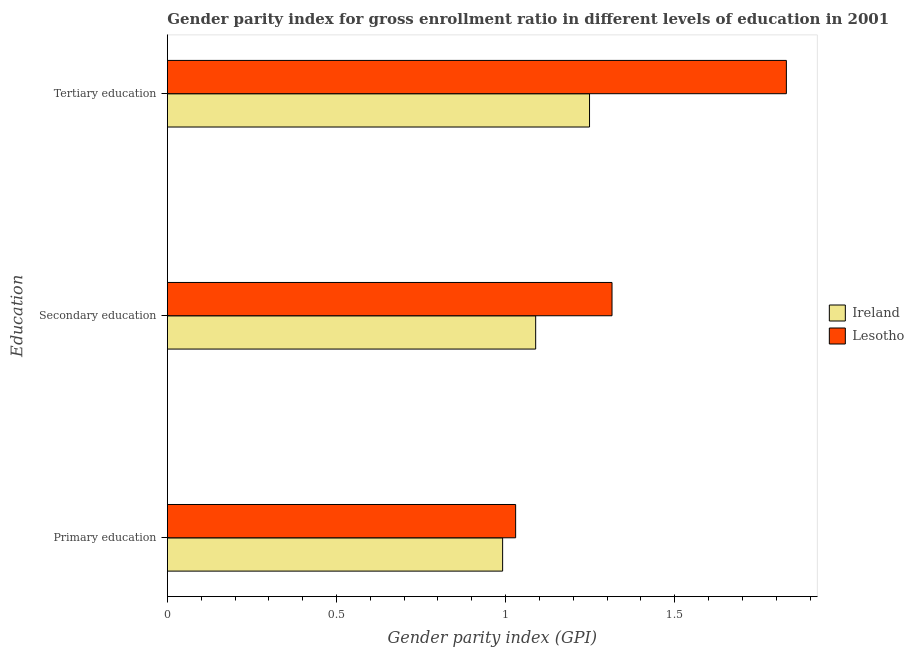How many different coloured bars are there?
Offer a terse response. 2. Are the number of bars per tick equal to the number of legend labels?
Keep it short and to the point. Yes. Are the number of bars on each tick of the Y-axis equal?
Your answer should be very brief. Yes. How many bars are there on the 1st tick from the top?
Ensure brevity in your answer.  2. What is the label of the 2nd group of bars from the top?
Keep it short and to the point. Secondary education. What is the gender parity index in secondary education in Ireland?
Make the answer very short. 1.09. Across all countries, what is the maximum gender parity index in primary education?
Offer a very short reply. 1.03. Across all countries, what is the minimum gender parity index in secondary education?
Keep it short and to the point. 1.09. In which country was the gender parity index in tertiary education maximum?
Give a very brief answer. Lesotho. In which country was the gender parity index in secondary education minimum?
Provide a succinct answer. Ireland. What is the total gender parity index in tertiary education in the graph?
Your response must be concise. 3.08. What is the difference between the gender parity index in tertiary education in Lesotho and that in Ireland?
Give a very brief answer. 0.58. What is the difference between the gender parity index in tertiary education in Lesotho and the gender parity index in secondary education in Ireland?
Offer a terse response. 0.74. What is the average gender parity index in primary education per country?
Provide a succinct answer. 1.01. What is the difference between the gender parity index in secondary education and gender parity index in primary education in Ireland?
Offer a very short reply. 0.1. What is the ratio of the gender parity index in secondary education in Ireland to that in Lesotho?
Provide a short and direct response. 0.83. Is the gender parity index in secondary education in Ireland less than that in Lesotho?
Give a very brief answer. Yes. Is the difference between the gender parity index in primary education in Lesotho and Ireland greater than the difference between the gender parity index in tertiary education in Lesotho and Ireland?
Provide a succinct answer. No. What is the difference between the highest and the second highest gender parity index in primary education?
Keep it short and to the point. 0.04. What is the difference between the highest and the lowest gender parity index in primary education?
Provide a short and direct response. 0.04. What does the 2nd bar from the top in Primary education represents?
Your answer should be compact. Ireland. What does the 1st bar from the bottom in Primary education represents?
Ensure brevity in your answer.  Ireland. Is it the case that in every country, the sum of the gender parity index in primary education and gender parity index in secondary education is greater than the gender parity index in tertiary education?
Keep it short and to the point. Yes. How many bars are there?
Offer a very short reply. 6. Are all the bars in the graph horizontal?
Your answer should be compact. Yes. What is the difference between two consecutive major ticks on the X-axis?
Offer a very short reply. 0.5. Are the values on the major ticks of X-axis written in scientific E-notation?
Provide a succinct answer. No. Where does the legend appear in the graph?
Make the answer very short. Center right. How are the legend labels stacked?
Make the answer very short. Vertical. What is the title of the graph?
Your response must be concise. Gender parity index for gross enrollment ratio in different levels of education in 2001. What is the label or title of the X-axis?
Offer a terse response. Gender parity index (GPI). What is the label or title of the Y-axis?
Make the answer very short. Education. What is the Gender parity index (GPI) in Ireland in Primary education?
Provide a short and direct response. 0.99. What is the Gender parity index (GPI) in Lesotho in Primary education?
Give a very brief answer. 1.03. What is the Gender parity index (GPI) of Ireland in Secondary education?
Offer a very short reply. 1.09. What is the Gender parity index (GPI) of Lesotho in Secondary education?
Offer a very short reply. 1.31. What is the Gender parity index (GPI) of Ireland in Tertiary education?
Your answer should be compact. 1.25. What is the Gender parity index (GPI) in Lesotho in Tertiary education?
Provide a short and direct response. 1.83. Across all Education, what is the maximum Gender parity index (GPI) of Ireland?
Provide a short and direct response. 1.25. Across all Education, what is the maximum Gender parity index (GPI) in Lesotho?
Keep it short and to the point. 1.83. Across all Education, what is the minimum Gender parity index (GPI) of Ireland?
Provide a succinct answer. 0.99. Across all Education, what is the minimum Gender parity index (GPI) in Lesotho?
Give a very brief answer. 1.03. What is the total Gender parity index (GPI) of Ireland in the graph?
Offer a very short reply. 3.33. What is the total Gender parity index (GPI) in Lesotho in the graph?
Provide a succinct answer. 4.17. What is the difference between the Gender parity index (GPI) in Ireland in Primary education and that in Secondary education?
Your answer should be very brief. -0.1. What is the difference between the Gender parity index (GPI) of Lesotho in Primary education and that in Secondary education?
Provide a succinct answer. -0.28. What is the difference between the Gender parity index (GPI) of Ireland in Primary education and that in Tertiary education?
Ensure brevity in your answer.  -0.26. What is the difference between the Gender parity index (GPI) in Lesotho in Primary education and that in Tertiary education?
Offer a terse response. -0.8. What is the difference between the Gender parity index (GPI) in Ireland in Secondary education and that in Tertiary education?
Your response must be concise. -0.16. What is the difference between the Gender parity index (GPI) in Lesotho in Secondary education and that in Tertiary education?
Your answer should be very brief. -0.52. What is the difference between the Gender parity index (GPI) of Ireland in Primary education and the Gender parity index (GPI) of Lesotho in Secondary education?
Provide a succinct answer. -0.32. What is the difference between the Gender parity index (GPI) in Ireland in Primary education and the Gender parity index (GPI) in Lesotho in Tertiary education?
Offer a terse response. -0.84. What is the difference between the Gender parity index (GPI) in Ireland in Secondary education and the Gender parity index (GPI) in Lesotho in Tertiary education?
Offer a terse response. -0.74. What is the average Gender parity index (GPI) of Ireland per Education?
Provide a short and direct response. 1.11. What is the average Gender parity index (GPI) of Lesotho per Education?
Your answer should be very brief. 1.39. What is the difference between the Gender parity index (GPI) in Ireland and Gender parity index (GPI) in Lesotho in Primary education?
Your answer should be compact. -0.04. What is the difference between the Gender parity index (GPI) in Ireland and Gender parity index (GPI) in Lesotho in Secondary education?
Your answer should be very brief. -0.23. What is the difference between the Gender parity index (GPI) in Ireland and Gender parity index (GPI) in Lesotho in Tertiary education?
Keep it short and to the point. -0.58. What is the ratio of the Gender parity index (GPI) of Ireland in Primary education to that in Secondary education?
Provide a short and direct response. 0.91. What is the ratio of the Gender parity index (GPI) in Lesotho in Primary education to that in Secondary education?
Your answer should be very brief. 0.78. What is the ratio of the Gender parity index (GPI) in Ireland in Primary education to that in Tertiary education?
Provide a short and direct response. 0.79. What is the ratio of the Gender parity index (GPI) in Lesotho in Primary education to that in Tertiary education?
Your response must be concise. 0.56. What is the ratio of the Gender parity index (GPI) of Ireland in Secondary education to that in Tertiary education?
Give a very brief answer. 0.87. What is the ratio of the Gender parity index (GPI) of Lesotho in Secondary education to that in Tertiary education?
Offer a very short reply. 0.72. What is the difference between the highest and the second highest Gender parity index (GPI) in Ireland?
Offer a very short reply. 0.16. What is the difference between the highest and the second highest Gender parity index (GPI) of Lesotho?
Make the answer very short. 0.52. What is the difference between the highest and the lowest Gender parity index (GPI) in Ireland?
Ensure brevity in your answer.  0.26. What is the difference between the highest and the lowest Gender parity index (GPI) in Lesotho?
Your answer should be very brief. 0.8. 